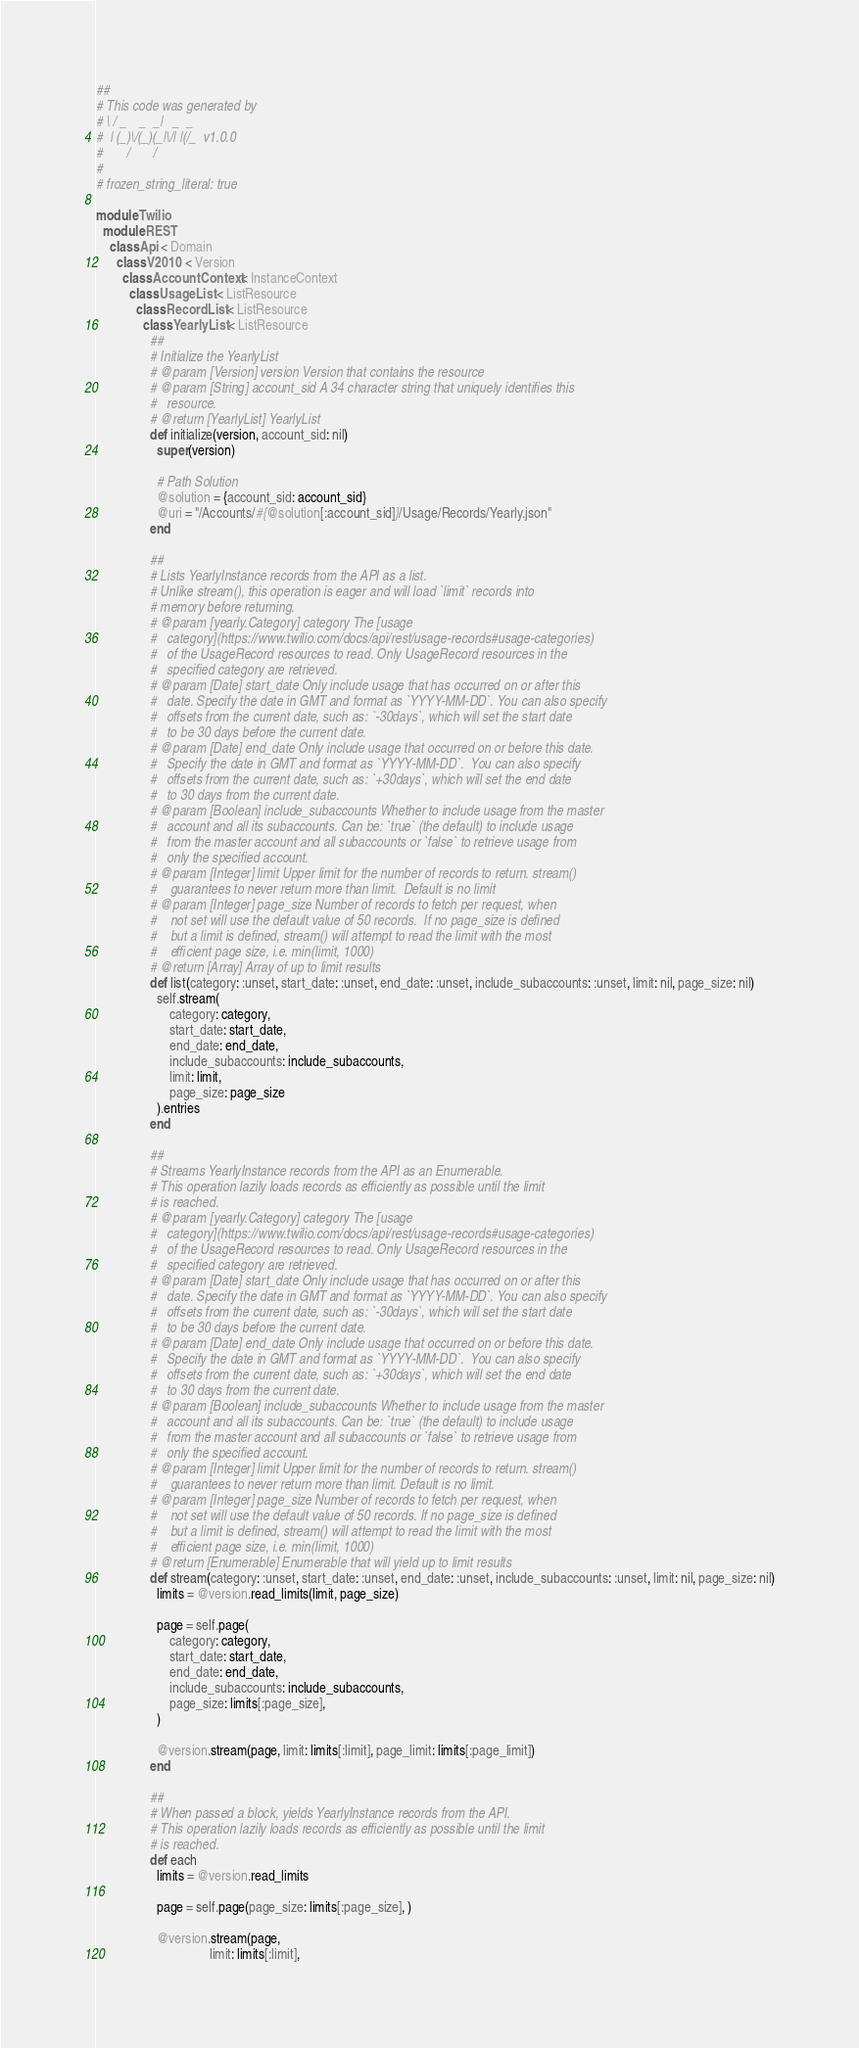<code> <loc_0><loc_0><loc_500><loc_500><_Ruby_>##
# This code was generated by
# \ / _    _  _|   _  _
#  | (_)\/(_)(_|\/| |(/_  v1.0.0
#       /       /
# 
# frozen_string_literal: true

module Twilio
  module REST
    class Api < Domain
      class V2010 < Version
        class AccountContext < InstanceContext
          class UsageList < ListResource
            class RecordList < ListResource
              class YearlyList < ListResource
                ##
                # Initialize the YearlyList
                # @param [Version] version Version that contains the resource
                # @param [String] account_sid A 34 character string that uniquely identifies this
                #   resource.
                # @return [YearlyList] YearlyList
                def initialize(version, account_sid: nil)
                  super(version)

                  # Path Solution
                  @solution = {account_sid: account_sid}
                  @uri = "/Accounts/#{@solution[:account_sid]}/Usage/Records/Yearly.json"
                end

                ##
                # Lists YearlyInstance records from the API as a list.
                # Unlike stream(), this operation is eager and will load `limit` records into
                # memory before returning.
                # @param [yearly.Category] category The [usage
                #   category](https://www.twilio.com/docs/api/rest/usage-records#usage-categories)
                #   of the UsageRecord resources to read. Only UsageRecord resources in the
                #   specified category are retrieved.
                # @param [Date] start_date Only include usage that has occurred on or after this
                #   date. Specify the date in GMT and format as `YYYY-MM-DD`. You can also specify
                #   offsets from the current date, such as: `-30days`, which will set the start date
                #   to be 30 days before the current date.
                # @param [Date] end_date Only include usage that occurred on or before this date.
                #   Specify the date in GMT and format as `YYYY-MM-DD`.  You can also specify
                #   offsets from the current date, such as: `+30days`, which will set the end date
                #   to 30 days from the current date.
                # @param [Boolean] include_subaccounts Whether to include usage from the master
                #   account and all its subaccounts. Can be: `true` (the default) to include usage
                #   from the master account and all subaccounts or `false` to retrieve usage from
                #   only the specified account.
                # @param [Integer] limit Upper limit for the number of records to return. stream()
                #    guarantees to never return more than limit.  Default is no limit
                # @param [Integer] page_size Number of records to fetch per request, when
                #    not set will use the default value of 50 records.  If no page_size is defined
                #    but a limit is defined, stream() will attempt to read the limit with the most
                #    efficient page size, i.e. min(limit, 1000)
                # @return [Array] Array of up to limit results
                def list(category: :unset, start_date: :unset, end_date: :unset, include_subaccounts: :unset, limit: nil, page_size: nil)
                  self.stream(
                      category: category,
                      start_date: start_date,
                      end_date: end_date,
                      include_subaccounts: include_subaccounts,
                      limit: limit,
                      page_size: page_size
                  ).entries
                end

                ##
                # Streams YearlyInstance records from the API as an Enumerable.
                # This operation lazily loads records as efficiently as possible until the limit
                # is reached.
                # @param [yearly.Category] category The [usage
                #   category](https://www.twilio.com/docs/api/rest/usage-records#usage-categories)
                #   of the UsageRecord resources to read. Only UsageRecord resources in the
                #   specified category are retrieved.
                # @param [Date] start_date Only include usage that has occurred on or after this
                #   date. Specify the date in GMT and format as `YYYY-MM-DD`. You can also specify
                #   offsets from the current date, such as: `-30days`, which will set the start date
                #   to be 30 days before the current date.
                # @param [Date] end_date Only include usage that occurred on or before this date.
                #   Specify the date in GMT and format as `YYYY-MM-DD`.  You can also specify
                #   offsets from the current date, such as: `+30days`, which will set the end date
                #   to 30 days from the current date.
                # @param [Boolean] include_subaccounts Whether to include usage from the master
                #   account and all its subaccounts. Can be: `true` (the default) to include usage
                #   from the master account and all subaccounts or `false` to retrieve usage from
                #   only the specified account.
                # @param [Integer] limit Upper limit for the number of records to return. stream()
                #    guarantees to never return more than limit. Default is no limit.
                # @param [Integer] page_size Number of records to fetch per request, when
                #    not set will use the default value of 50 records. If no page_size is defined
                #    but a limit is defined, stream() will attempt to read the limit with the most
                #    efficient page size, i.e. min(limit, 1000)
                # @return [Enumerable] Enumerable that will yield up to limit results
                def stream(category: :unset, start_date: :unset, end_date: :unset, include_subaccounts: :unset, limit: nil, page_size: nil)
                  limits = @version.read_limits(limit, page_size)

                  page = self.page(
                      category: category,
                      start_date: start_date,
                      end_date: end_date,
                      include_subaccounts: include_subaccounts,
                      page_size: limits[:page_size],
                  )

                  @version.stream(page, limit: limits[:limit], page_limit: limits[:page_limit])
                end

                ##
                # When passed a block, yields YearlyInstance records from the API.
                # This operation lazily loads records as efficiently as possible until the limit
                # is reached.
                def each
                  limits = @version.read_limits

                  page = self.page(page_size: limits[:page_size], )

                  @version.stream(page,
                                  limit: limits[:limit],</code> 